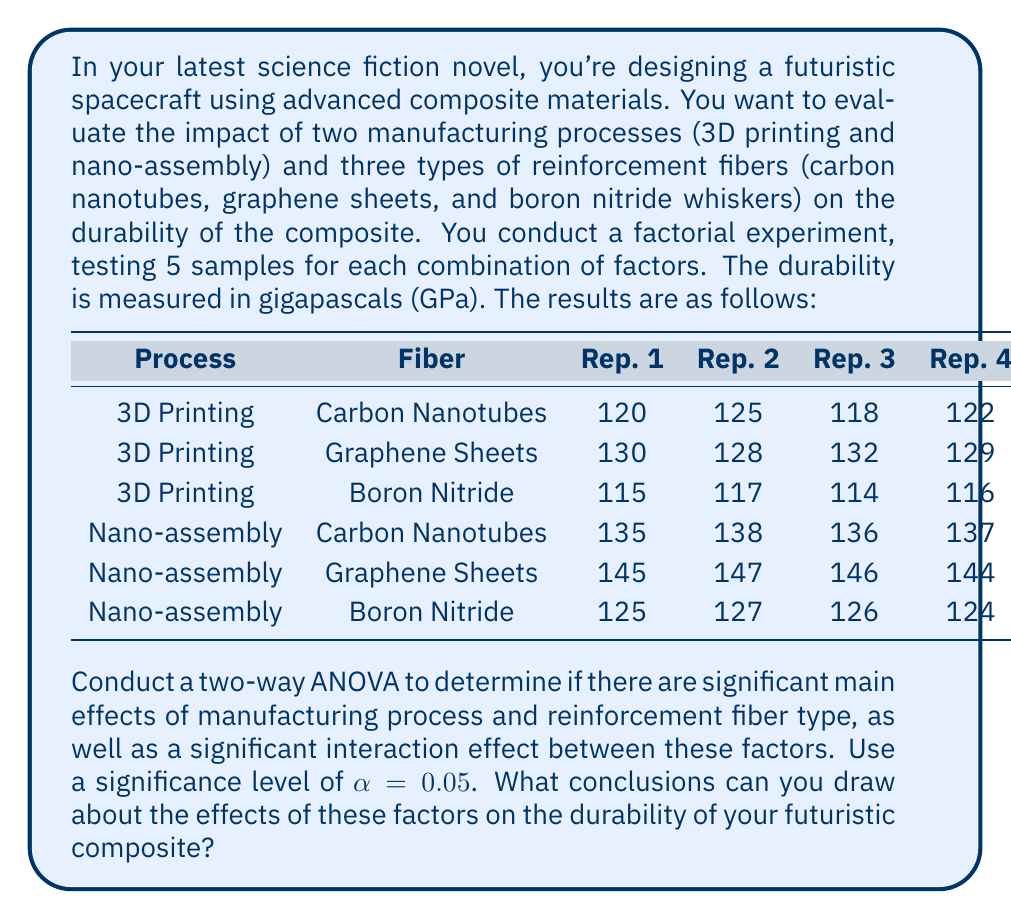Solve this math problem. To conduct a two-way ANOVA, we need to follow these steps:

1. Calculate the sum of squares for each source of variation: Total (SST), Factor A (SSA), Factor B (SSB), Interaction (SSAB), and Error (SSE).
2. Calculate the degrees of freedom for each source.
3. Calculate the mean squares for each source.
4. Calculate the F-ratios for main effects and interaction.
5. Compare F-ratios to critical F-values to determine significance.

Let's go through each step:

1. Sum of Squares calculations:

   Total Sum of Squares (SST):
   $$SST = \sum_{i=1}^a \sum_{j=1}^b \sum_{k=1}^n (Y_{ijk} - \bar{Y})^2 = 13,690$$

   Sum of Squares for Factor A (Manufacturing Process):
   $$SSA = bn\sum_{i=1}^a (\bar{Y}_{i..} - \bar{Y})^2 = 5,400$$

   Sum of Squares for Factor B (Reinforcement Fiber):
   $$SSB = an\sum_{j=1}^b (\bar{Y}_{.j.} - \bar{Y})^2 = 7,260$$

   Sum of Squares for Interaction:
   $$SSAB = n\sum_{i=1}^a \sum_{j=1}^b (\bar{Y}_{ij.} - \bar{Y}_{i..} - \bar{Y}_{.j.} + \bar{Y})^2 = 900$$

   Sum of Squares for Error:
   $$SSE = SST - SSA - SSB - SSAB = 130$$

2. Degrees of freedom:
   - Factor A: $df_A = a - 1 = 1$
   - Factor B: $df_B = b - 1 = 2$
   - Interaction: $df_{AB} = (a-1)(b-1) = 2$
   - Error: $df_E = ab(n-1) = 24$
   - Total: $df_T = abn - 1 = 29$

3. Mean Squares:
   $$MS_A = \frac{SSA}{df_A} = 5,400$$
   $$MS_B = \frac{SSB}{df_B} = 3,630$$
   $$MS_{AB} = \frac{SSAB}{df_{AB}} = 450$$
   $$MS_E = \frac{SSE}{df_E} = 5.417$$

4. F-ratios:
   $$F_A = \frac{MS_A}{MS_E} = 996.86$$
   $$F_B = \frac{MS_B}{MS_E} = 670.11$$
   $$F_{AB} = \frac{MS_{AB}}{MS_E} = 83.07$$

5. Critical F-values (at $\alpha = 0.05$):
   $$F_{crit(A)} = F_{0.05,1,24} = 4.26$$
   $$F_{crit(B)} = F_{0.05,2,24} = 3.40$$
   $$F_{crit(AB)} = F_{0.05,2,24} = 3.40$$

Comparing the calculated F-ratios to the critical F-values, we can see that all F-ratios are much larger than their respective critical values. This means that both main effects and the interaction effect are statistically significant at the 0.05 level.
Answer: Based on the two-way ANOVA results, we can conclude:

1. There is a significant main effect of the manufacturing process on composite durability (F = 996.86, p < 0.05).
2. There is a significant main effect of the reinforcement fiber type on composite durability (F = 670.11, p < 0.05).
3. There is a significant interaction effect between manufacturing process and reinforcement fiber type on composite durability (F = 83.07, p < 0.05).

These results suggest that both the manufacturing process and the choice of reinforcement fiber significantly affect the durability of the futuristic composite material. Additionally, the significant interaction effect indicates that the impact of the manufacturing process on durability depends on the type of reinforcement fiber used, and vice versa. For the science fiction novel, this implies that careful consideration must be given to both factors when designing the spacecraft's composite materials to optimize durability. 